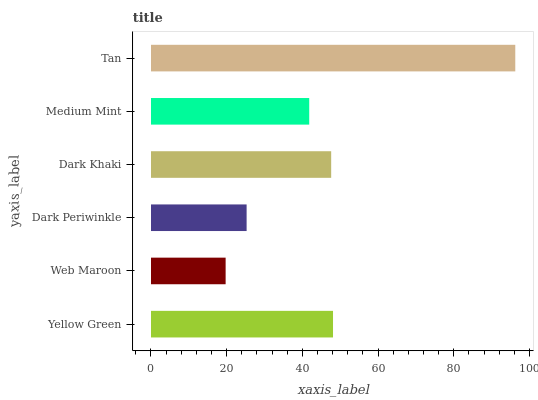Is Web Maroon the minimum?
Answer yes or no. Yes. Is Tan the maximum?
Answer yes or no. Yes. Is Dark Periwinkle the minimum?
Answer yes or no. No. Is Dark Periwinkle the maximum?
Answer yes or no. No. Is Dark Periwinkle greater than Web Maroon?
Answer yes or no. Yes. Is Web Maroon less than Dark Periwinkle?
Answer yes or no. Yes. Is Web Maroon greater than Dark Periwinkle?
Answer yes or no. No. Is Dark Periwinkle less than Web Maroon?
Answer yes or no. No. Is Dark Khaki the high median?
Answer yes or no. Yes. Is Medium Mint the low median?
Answer yes or no. Yes. Is Yellow Green the high median?
Answer yes or no. No. Is Dark Khaki the low median?
Answer yes or no. No. 